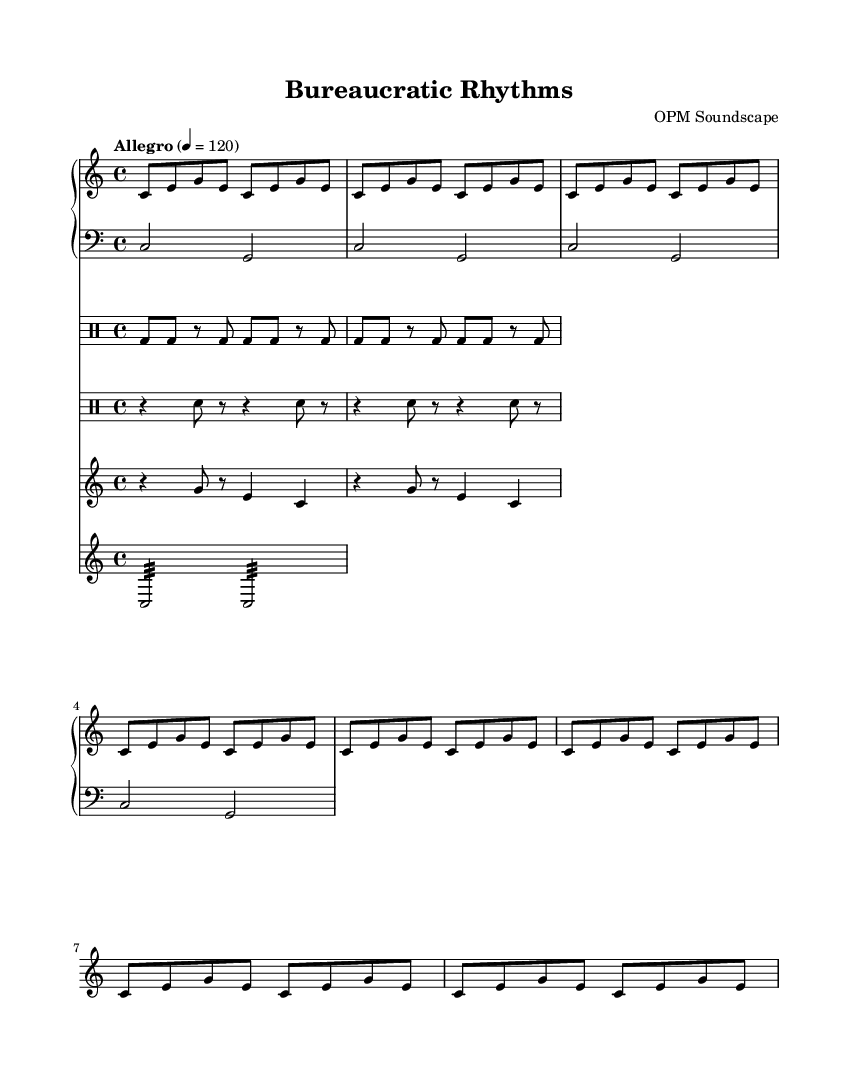What is the title of this piece? The title is stated in the header section of the music sheet, which indicates the work being presented.
Answer: Bureaucratic Rhythms What is the composer of this music? The composer is also included in the header section, providing the name associated with the music.
Answer: OPM Soundscape What is the time signature of this music? The time signature is specified in the global settings of the music sheet, which shows how beats in a measure are organized.
Answer: 4/4 What is the tempo marking for this piece? The tempo marking is indicated in the global settings, showing the pace at which the piece should be played.
Answer: Allegro How many measures does the typewriter pattern repeat? The typewriter pattern, as indicated in the drum staff, repeats a specific number of times which can be observed in the notation.
Answer: 2 What kind of instruments are used in this composition? The instruments can be identified from the staff types presented in the score, each representing a different sound source contributing to the overall soundscape.
Answer: Piano, Drum, Staff What type of sounds are included in the piece in relation to office equipment? The specific sounds produced by common office equipment can be discerned by examining the labeled components and their corresponding rhythmic notations.
Answer: Typewriter, Stapler, Fax Machine, Paper Shredder 